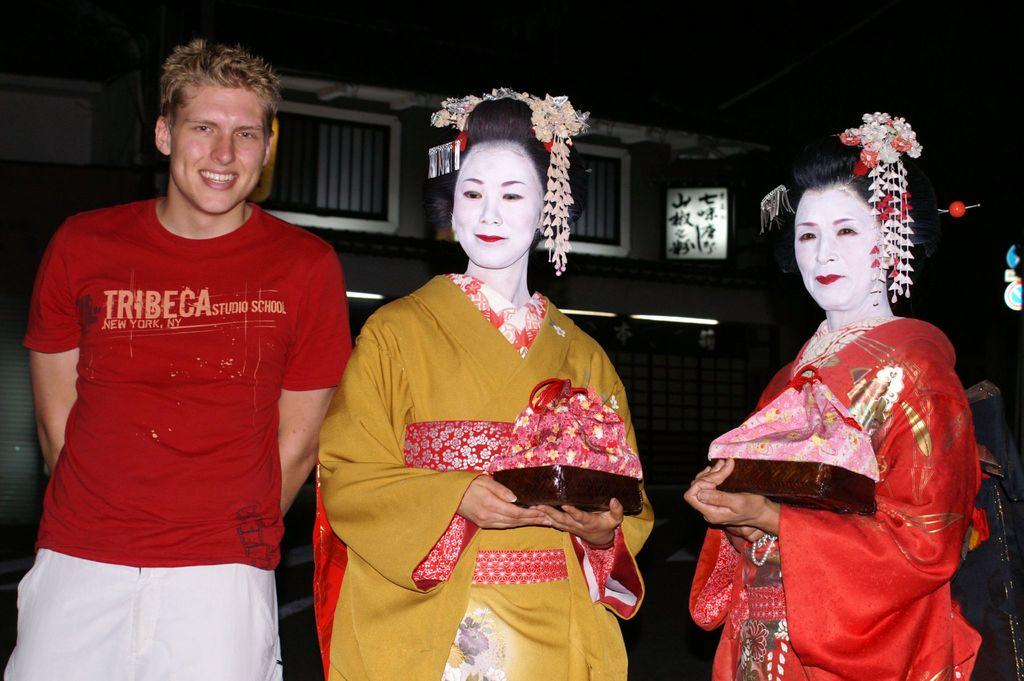<image>
Describe the image concisely. A white man in a Tribeca t-shirt stands next to two geisha. 